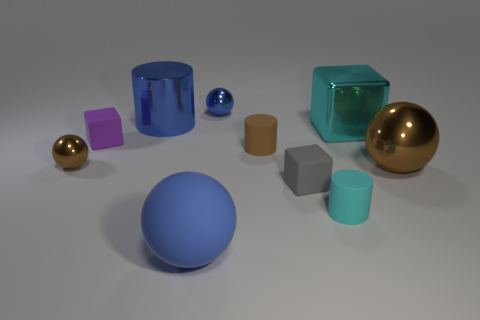Is there anything else that has the same size as the gray matte block?
Make the answer very short. Yes. Do the blue object that is right of the big blue matte object and the small metal object that is in front of the small brown cylinder have the same shape?
Provide a short and direct response. Yes. The cyan metal object has what size?
Your answer should be very brief. Large. The purple cube in front of the big blue object behind the ball left of the big cylinder is made of what material?
Offer a very short reply. Rubber. What number of other things are there of the same color as the metallic cylinder?
Your answer should be compact. 2. How many red objects are matte cylinders or shiny cylinders?
Keep it short and to the point. 0. There is a brown sphere that is on the left side of the tiny cyan cylinder; what is it made of?
Provide a succinct answer. Metal. Is the material of the cube in front of the purple rubber block the same as the big cube?
Keep it short and to the point. No. What shape is the small blue metal object?
Your response must be concise. Sphere. What number of rubber balls are behind the metal sphere behind the brown metallic ball that is on the left side of the tiny gray rubber thing?
Offer a terse response. 0. 